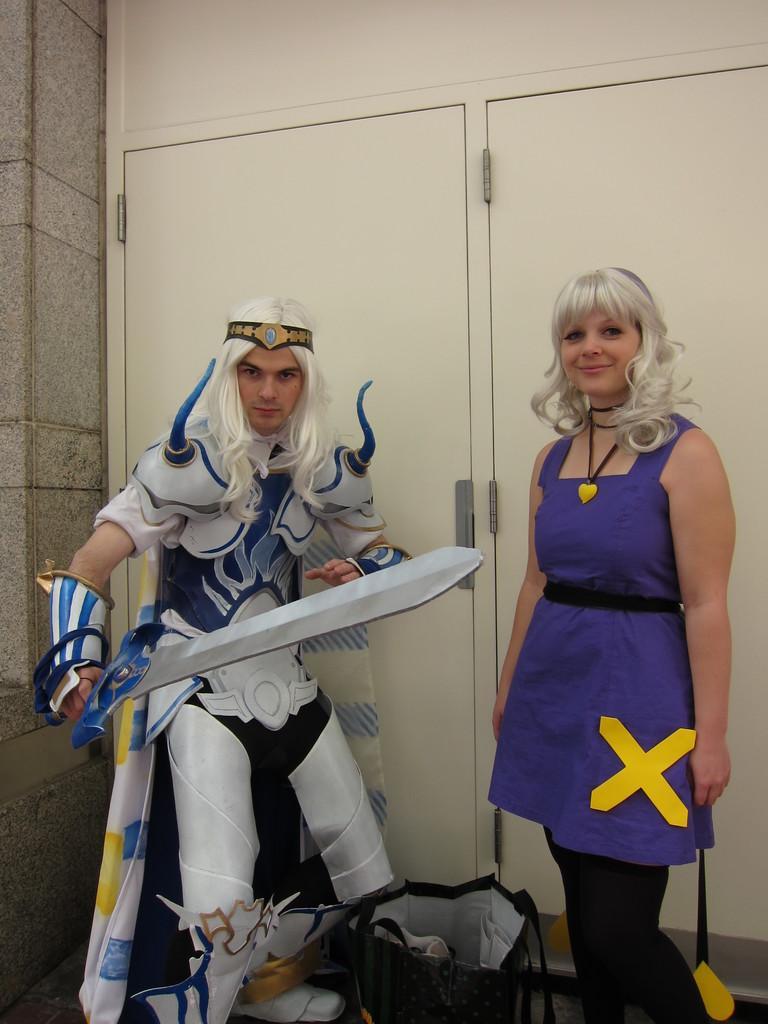Please provide a concise description of this image. On the right side there is a lady. And there is another person wearing a costume and holding a sword. In the back there are doors. 